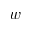<formula> <loc_0><loc_0><loc_500><loc_500>w</formula> 